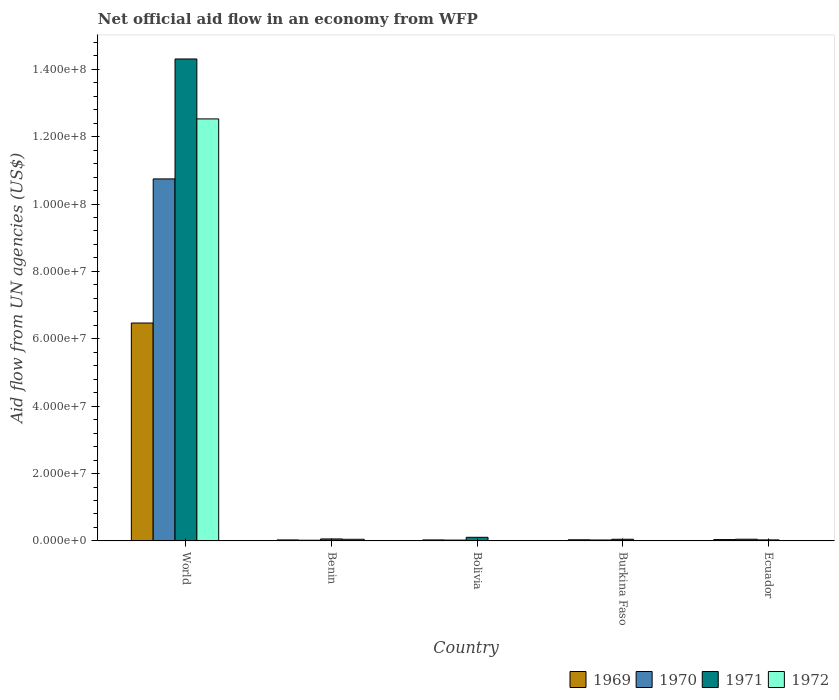How many groups of bars are there?
Ensure brevity in your answer.  5. How many bars are there on the 2nd tick from the left?
Provide a succinct answer. 4. How many bars are there on the 2nd tick from the right?
Ensure brevity in your answer.  4. What is the label of the 1st group of bars from the left?
Your response must be concise. World. In how many cases, is the number of bars for a given country not equal to the number of legend labels?
Provide a succinct answer. 1. What is the net official aid flow in 1972 in World?
Your response must be concise. 1.25e+08. Across all countries, what is the maximum net official aid flow in 1970?
Your answer should be very brief. 1.07e+08. Across all countries, what is the minimum net official aid flow in 1971?
Make the answer very short. 3.10e+05. In which country was the net official aid flow in 1969 maximum?
Provide a succinct answer. World. What is the total net official aid flow in 1972 in the graph?
Give a very brief answer. 1.26e+08. What is the difference between the net official aid flow in 1970 in Benin and that in Ecuador?
Offer a very short reply. -3.00e+05. What is the difference between the net official aid flow in 1971 in Burkina Faso and the net official aid flow in 1970 in Ecuador?
Keep it short and to the point. -10000. What is the average net official aid flow in 1970 per country?
Your answer should be very brief. 2.17e+07. What is the difference between the net official aid flow of/in 1970 and net official aid flow of/in 1971 in Bolivia?
Keep it short and to the point. -8.30e+05. In how many countries, is the net official aid flow in 1970 greater than 64000000 US$?
Keep it short and to the point. 1. What is the ratio of the net official aid flow in 1971 in Ecuador to that in World?
Your answer should be very brief. 0. Is the net official aid flow in 1969 in Benin less than that in Bolivia?
Give a very brief answer. No. What is the difference between the highest and the second highest net official aid flow in 1970?
Give a very brief answer. 1.07e+08. What is the difference between the highest and the lowest net official aid flow in 1970?
Ensure brevity in your answer.  1.07e+08. Is the sum of the net official aid flow in 1972 in Ecuador and World greater than the maximum net official aid flow in 1970 across all countries?
Your response must be concise. Yes. Is it the case that in every country, the sum of the net official aid flow in 1972 and net official aid flow in 1971 is greater than the net official aid flow in 1970?
Your answer should be very brief. No. How many bars are there?
Provide a short and direct response. 19. Are all the bars in the graph horizontal?
Your response must be concise. No. What is the difference between two consecutive major ticks on the Y-axis?
Ensure brevity in your answer.  2.00e+07. Are the values on the major ticks of Y-axis written in scientific E-notation?
Ensure brevity in your answer.  Yes. How many legend labels are there?
Offer a terse response. 4. What is the title of the graph?
Keep it short and to the point. Net official aid flow in an economy from WFP. What is the label or title of the X-axis?
Your response must be concise. Country. What is the label or title of the Y-axis?
Your response must be concise. Aid flow from UN agencies (US$). What is the Aid flow from UN agencies (US$) in 1969 in World?
Give a very brief answer. 6.47e+07. What is the Aid flow from UN agencies (US$) of 1970 in World?
Offer a very short reply. 1.07e+08. What is the Aid flow from UN agencies (US$) in 1971 in World?
Give a very brief answer. 1.43e+08. What is the Aid flow from UN agencies (US$) in 1972 in World?
Offer a very short reply. 1.25e+08. What is the Aid flow from UN agencies (US$) in 1969 in Benin?
Your answer should be very brief. 3.00e+05. What is the Aid flow from UN agencies (US$) of 1971 in Benin?
Provide a succinct answer. 5.90e+05. What is the Aid flow from UN agencies (US$) of 1971 in Bolivia?
Ensure brevity in your answer.  1.08e+06. What is the Aid flow from UN agencies (US$) in 1969 in Burkina Faso?
Make the answer very short. 3.40e+05. What is the Aid flow from UN agencies (US$) in 1972 in Burkina Faso?
Give a very brief answer. 9.00e+04. What is the Aid flow from UN agencies (US$) of 1969 in Ecuador?
Provide a short and direct response. 4.00e+05. What is the Aid flow from UN agencies (US$) in 1970 in Ecuador?
Offer a very short reply. 5.10e+05. What is the Aid flow from UN agencies (US$) of 1972 in Ecuador?
Give a very brief answer. 7.00e+04. Across all countries, what is the maximum Aid flow from UN agencies (US$) in 1969?
Your answer should be very brief. 6.47e+07. Across all countries, what is the maximum Aid flow from UN agencies (US$) in 1970?
Provide a succinct answer. 1.07e+08. Across all countries, what is the maximum Aid flow from UN agencies (US$) of 1971?
Provide a short and direct response. 1.43e+08. Across all countries, what is the maximum Aid flow from UN agencies (US$) in 1972?
Your response must be concise. 1.25e+08. Across all countries, what is the minimum Aid flow from UN agencies (US$) of 1969?
Offer a very short reply. 3.00e+05. Across all countries, what is the minimum Aid flow from UN agencies (US$) of 1970?
Ensure brevity in your answer.  2.10e+05. Across all countries, what is the minimum Aid flow from UN agencies (US$) of 1972?
Ensure brevity in your answer.  0. What is the total Aid flow from UN agencies (US$) in 1969 in the graph?
Keep it short and to the point. 6.60e+07. What is the total Aid flow from UN agencies (US$) of 1970 in the graph?
Offer a very short reply. 1.09e+08. What is the total Aid flow from UN agencies (US$) of 1971 in the graph?
Your response must be concise. 1.46e+08. What is the total Aid flow from UN agencies (US$) in 1972 in the graph?
Keep it short and to the point. 1.26e+08. What is the difference between the Aid flow from UN agencies (US$) of 1969 in World and that in Benin?
Offer a very short reply. 6.44e+07. What is the difference between the Aid flow from UN agencies (US$) of 1970 in World and that in Benin?
Keep it short and to the point. 1.07e+08. What is the difference between the Aid flow from UN agencies (US$) in 1971 in World and that in Benin?
Make the answer very short. 1.42e+08. What is the difference between the Aid flow from UN agencies (US$) in 1972 in World and that in Benin?
Make the answer very short. 1.25e+08. What is the difference between the Aid flow from UN agencies (US$) in 1969 in World and that in Bolivia?
Offer a terse response. 6.44e+07. What is the difference between the Aid flow from UN agencies (US$) of 1970 in World and that in Bolivia?
Offer a very short reply. 1.07e+08. What is the difference between the Aid flow from UN agencies (US$) of 1971 in World and that in Bolivia?
Offer a terse response. 1.42e+08. What is the difference between the Aid flow from UN agencies (US$) of 1969 in World and that in Burkina Faso?
Your answer should be compact. 6.44e+07. What is the difference between the Aid flow from UN agencies (US$) in 1970 in World and that in Burkina Faso?
Make the answer very short. 1.07e+08. What is the difference between the Aid flow from UN agencies (US$) of 1971 in World and that in Burkina Faso?
Provide a succinct answer. 1.43e+08. What is the difference between the Aid flow from UN agencies (US$) in 1972 in World and that in Burkina Faso?
Give a very brief answer. 1.25e+08. What is the difference between the Aid flow from UN agencies (US$) in 1969 in World and that in Ecuador?
Provide a succinct answer. 6.43e+07. What is the difference between the Aid flow from UN agencies (US$) of 1970 in World and that in Ecuador?
Your response must be concise. 1.07e+08. What is the difference between the Aid flow from UN agencies (US$) of 1971 in World and that in Ecuador?
Offer a very short reply. 1.43e+08. What is the difference between the Aid flow from UN agencies (US$) of 1972 in World and that in Ecuador?
Offer a terse response. 1.25e+08. What is the difference between the Aid flow from UN agencies (US$) in 1971 in Benin and that in Bolivia?
Keep it short and to the point. -4.90e+05. What is the difference between the Aid flow from UN agencies (US$) in 1971 in Benin and that in Burkina Faso?
Your answer should be very brief. 9.00e+04. What is the difference between the Aid flow from UN agencies (US$) in 1971 in Benin and that in Ecuador?
Your answer should be very brief. 2.80e+05. What is the difference between the Aid flow from UN agencies (US$) of 1972 in Benin and that in Ecuador?
Keep it short and to the point. 4.20e+05. What is the difference between the Aid flow from UN agencies (US$) in 1970 in Bolivia and that in Burkina Faso?
Provide a short and direct response. -3.00e+04. What is the difference between the Aid flow from UN agencies (US$) in 1971 in Bolivia and that in Burkina Faso?
Keep it short and to the point. 5.80e+05. What is the difference between the Aid flow from UN agencies (US$) of 1969 in Bolivia and that in Ecuador?
Make the answer very short. -1.00e+05. What is the difference between the Aid flow from UN agencies (US$) in 1971 in Bolivia and that in Ecuador?
Your response must be concise. 7.70e+05. What is the difference between the Aid flow from UN agencies (US$) in 1969 in Burkina Faso and that in Ecuador?
Your answer should be very brief. -6.00e+04. What is the difference between the Aid flow from UN agencies (US$) in 1970 in Burkina Faso and that in Ecuador?
Make the answer very short. -2.30e+05. What is the difference between the Aid flow from UN agencies (US$) of 1971 in Burkina Faso and that in Ecuador?
Your answer should be compact. 1.90e+05. What is the difference between the Aid flow from UN agencies (US$) of 1972 in Burkina Faso and that in Ecuador?
Your answer should be very brief. 2.00e+04. What is the difference between the Aid flow from UN agencies (US$) in 1969 in World and the Aid flow from UN agencies (US$) in 1970 in Benin?
Your answer should be very brief. 6.45e+07. What is the difference between the Aid flow from UN agencies (US$) of 1969 in World and the Aid flow from UN agencies (US$) of 1971 in Benin?
Offer a very short reply. 6.41e+07. What is the difference between the Aid flow from UN agencies (US$) in 1969 in World and the Aid flow from UN agencies (US$) in 1972 in Benin?
Offer a terse response. 6.42e+07. What is the difference between the Aid flow from UN agencies (US$) of 1970 in World and the Aid flow from UN agencies (US$) of 1971 in Benin?
Make the answer very short. 1.07e+08. What is the difference between the Aid flow from UN agencies (US$) of 1970 in World and the Aid flow from UN agencies (US$) of 1972 in Benin?
Keep it short and to the point. 1.07e+08. What is the difference between the Aid flow from UN agencies (US$) of 1971 in World and the Aid flow from UN agencies (US$) of 1972 in Benin?
Your answer should be very brief. 1.43e+08. What is the difference between the Aid flow from UN agencies (US$) of 1969 in World and the Aid flow from UN agencies (US$) of 1970 in Bolivia?
Ensure brevity in your answer.  6.44e+07. What is the difference between the Aid flow from UN agencies (US$) of 1969 in World and the Aid flow from UN agencies (US$) of 1971 in Bolivia?
Make the answer very short. 6.36e+07. What is the difference between the Aid flow from UN agencies (US$) in 1970 in World and the Aid flow from UN agencies (US$) in 1971 in Bolivia?
Provide a short and direct response. 1.06e+08. What is the difference between the Aid flow from UN agencies (US$) of 1969 in World and the Aid flow from UN agencies (US$) of 1970 in Burkina Faso?
Provide a short and direct response. 6.44e+07. What is the difference between the Aid flow from UN agencies (US$) in 1969 in World and the Aid flow from UN agencies (US$) in 1971 in Burkina Faso?
Your answer should be compact. 6.42e+07. What is the difference between the Aid flow from UN agencies (US$) of 1969 in World and the Aid flow from UN agencies (US$) of 1972 in Burkina Faso?
Offer a terse response. 6.46e+07. What is the difference between the Aid flow from UN agencies (US$) in 1970 in World and the Aid flow from UN agencies (US$) in 1971 in Burkina Faso?
Provide a short and direct response. 1.07e+08. What is the difference between the Aid flow from UN agencies (US$) of 1970 in World and the Aid flow from UN agencies (US$) of 1972 in Burkina Faso?
Your answer should be very brief. 1.07e+08. What is the difference between the Aid flow from UN agencies (US$) of 1971 in World and the Aid flow from UN agencies (US$) of 1972 in Burkina Faso?
Give a very brief answer. 1.43e+08. What is the difference between the Aid flow from UN agencies (US$) of 1969 in World and the Aid flow from UN agencies (US$) of 1970 in Ecuador?
Make the answer very short. 6.42e+07. What is the difference between the Aid flow from UN agencies (US$) in 1969 in World and the Aid flow from UN agencies (US$) in 1971 in Ecuador?
Your answer should be compact. 6.44e+07. What is the difference between the Aid flow from UN agencies (US$) of 1969 in World and the Aid flow from UN agencies (US$) of 1972 in Ecuador?
Your answer should be very brief. 6.46e+07. What is the difference between the Aid flow from UN agencies (US$) in 1970 in World and the Aid flow from UN agencies (US$) in 1971 in Ecuador?
Provide a succinct answer. 1.07e+08. What is the difference between the Aid flow from UN agencies (US$) of 1970 in World and the Aid flow from UN agencies (US$) of 1972 in Ecuador?
Provide a short and direct response. 1.07e+08. What is the difference between the Aid flow from UN agencies (US$) of 1971 in World and the Aid flow from UN agencies (US$) of 1972 in Ecuador?
Offer a very short reply. 1.43e+08. What is the difference between the Aid flow from UN agencies (US$) in 1969 in Benin and the Aid flow from UN agencies (US$) in 1970 in Bolivia?
Make the answer very short. 5.00e+04. What is the difference between the Aid flow from UN agencies (US$) of 1969 in Benin and the Aid flow from UN agencies (US$) of 1971 in Bolivia?
Offer a very short reply. -7.80e+05. What is the difference between the Aid flow from UN agencies (US$) of 1970 in Benin and the Aid flow from UN agencies (US$) of 1971 in Bolivia?
Give a very brief answer. -8.70e+05. What is the difference between the Aid flow from UN agencies (US$) of 1969 in Benin and the Aid flow from UN agencies (US$) of 1970 in Burkina Faso?
Provide a succinct answer. 2.00e+04. What is the difference between the Aid flow from UN agencies (US$) of 1969 in Benin and the Aid flow from UN agencies (US$) of 1971 in Burkina Faso?
Offer a terse response. -2.00e+05. What is the difference between the Aid flow from UN agencies (US$) of 1969 in Benin and the Aid flow from UN agencies (US$) of 1972 in Burkina Faso?
Make the answer very short. 2.10e+05. What is the difference between the Aid flow from UN agencies (US$) of 1970 in Benin and the Aid flow from UN agencies (US$) of 1972 in Burkina Faso?
Provide a succinct answer. 1.20e+05. What is the difference between the Aid flow from UN agencies (US$) in 1969 in Benin and the Aid flow from UN agencies (US$) in 1971 in Ecuador?
Ensure brevity in your answer.  -10000. What is the difference between the Aid flow from UN agencies (US$) in 1969 in Benin and the Aid flow from UN agencies (US$) in 1972 in Ecuador?
Provide a short and direct response. 2.30e+05. What is the difference between the Aid flow from UN agencies (US$) in 1970 in Benin and the Aid flow from UN agencies (US$) in 1971 in Ecuador?
Offer a very short reply. -1.00e+05. What is the difference between the Aid flow from UN agencies (US$) in 1970 in Benin and the Aid flow from UN agencies (US$) in 1972 in Ecuador?
Your answer should be compact. 1.40e+05. What is the difference between the Aid flow from UN agencies (US$) of 1971 in Benin and the Aid flow from UN agencies (US$) of 1972 in Ecuador?
Your response must be concise. 5.20e+05. What is the difference between the Aid flow from UN agencies (US$) of 1969 in Bolivia and the Aid flow from UN agencies (US$) of 1970 in Burkina Faso?
Offer a terse response. 2.00e+04. What is the difference between the Aid flow from UN agencies (US$) of 1969 in Bolivia and the Aid flow from UN agencies (US$) of 1971 in Burkina Faso?
Provide a succinct answer. -2.00e+05. What is the difference between the Aid flow from UN agencies (US$) in 1969 in Bolivia and the Aid flow from UN agencies (US$) in 1972 in Burkina Faso?
Provide a short and direct response. 2.10e+05. What is the difference between the Aid flow from UN agencies (US$) of 1970 in Bolivia and the Aid flow from UN agencies (US$) of 1971 in Burkina Faso?
Provide a short and direct response. -2.50e+05. What is the difference between the Aid flow from UN agencies (US$) of 1970 in Bolivia and the Aid flow from UN agencies (US$) of 1972 in Burkina Faso?
Give a very brief answer. 1.60e+05. What is the difference between the Aid flow from UN agencies (US$) in 1971 in Bolivia and the Aid flow from UN agencies (US$) in 1972 in Burkina Faso?
Make the answer very short. 9.90e+05. What is the difference between the Aid flow from UN agencies (US$) in 1969 in Bolivia and the Aid flow from UN agencies (US$) in 1971 in Ecuador?
Your answer should be compact. -10000. What is the difference between the Aid flow from UN agencies (US$) in 1969 in Bolivia and the Aid flow from UN agencies (US$) in 1972 in Ecuador?
Offer a very short reply. 2.30e+05. What is the difference between the Aid flow from UN agencies (US$) in 1970 in Bolivia and the Aid flow from UN agencies (US$) in 1971 in Ecuador?
Keep it short and to the point. -6.00e+04. What is the difference between the Aid flow from UN agencies (US$) of 1971 in Bolivia and the Aid flow from UN agencies (US$) of 1972 in Ecuador?
Make the answer very short. 1.01e+06. What is the difference between the Aid flow from UN agencies (US$) of 1970 in Burkina Faso and the Aid flow from UN agencies (US$) of 1971 in Ecuador?
Ensure brevity in your answer.  -3.00e+04. What is the difference between the Aid flow from UN agencies (US$) in 1970 in Burkina Faso and the Aid flow from UN agencies (US$) in 1972 in Ecuador?
Offer a terse response. 2.10e+05. What is the average Aid flow from UN agencies (US$) of 1969 per country?
Offer a very short reply. 1.32e+07. What is the average Aid flow from UN agencies (US$) of 1970 per country?
Your answer should be compact. 2.17e+07. What is the average Aid flow from UN agencies (US$) in 1971 per country?
Give a very brief answer. 2.91e+07. What is the average Aid flow from UN agencies (US$) of 1972 per country?
Keep it short and to the point. 2.52e+07. What is the difference between the Aid flow from UN agencies (US$) of 1969 and Aid flow from UN agencies (US$) of 1970 in World?
Give a very brief answer. -4.28e+07. What is the difference between the Aid flow from UN agencies (US$) in 1969 and Aid flow from UN agencies (US$) in 1971 in World?
Offer a terse response. -7.84e+07. What is the difference between the Aid flow from UN agencies (US$) in 1969 and Aid flow from UN agencies (US$) in 1972 in World?
Ensure brevity in your answer.  -6.06e+07. What is the difference between the Aid flow from UN agencies (US$) of 1970 and Aid flow from UN agencies (US$) of 1971 in World?
Your answer should be compact. -3.56e+07. What is the difference between the Aid flow from UN agencies (US$) of 1970 and Aid flow from UN agencies (US$) of 1972 in World?
Your answer should be very brief. -1.78e+07. What is the difference between the Aid flow from UN agencies (US$) in 1971 and Aid flow from UN agencies (US$) in 1972 in World?
Provide a short and direct response. 1.78e+07. What is the difference between the Aid flow from UN agencies (US$) of 1969 and Aid flow from UN agencies (US$) of 1970 in Benin?
Your response must be concise. 9.00e+04. What is the difference between the Aid flow from UN agencies (US$) in 1969 and Aid flow from UN agencies (US$) in 1972 in Benin?
Your response must be concise. -1.90e+05. What is the difference between the Aid flow from UN agencies (US$) in 1970 and Aid flow from UN agencies (US$) in 1971 in Benin?
Your response must be concise. -3.80e+05. What is the difference between the Aid flow from UN agencies (US$) in 1970 and Aid flow from UN agencies (US$) in 1972 in Benin?
Offer a terse response. -2.80e+05. What is the difference between the Aid flow from UN agencies (US$) in 1969 and Aid flow from UN agencies (US$) in 1970 in Bolivia?
Provide a short and direct response. 5.00e+04. What is the difference between the Aid flow from UN agencies (US$) of 1969 and Aid flow from UN agencies (US$) of 1971 in Bolivia?
Provide a succinct answer. -7.80e+05. What is the difference between the Aid flow from UN agencies (US$) in 1970 and Aid flow from UN agencies (US$) in 1971 in Bolivia?
Give a very brief answer. -8.30e+05. What is the difference between the Aid flow from UN agencies (US$) of 1969 and Aid flow from UN agencies (US$) of 1971 in Burkina Faso?
Your answer should be very brief. -1.60e+05. What is the difference between the Aid flow from UN agencies (US$) in 1970 and Aid flow from UN agencies (US$) in 1972 in Burkina Faso?
Offer a very short reply. 1.90e+05. What is the difference between the Aid flow from UN agencies (US$) in 1971 and Aid flow from UN agencies (US$) in 1972 in Burkina Faso?
Offer a very short reply. 4.10e+05. What is the difference between the Aid flow from UN agencies (US$) of 1969 and Aid flow from UN agencies (US$) of 1970 in Ecuador?
Provide a succinct answer. -1.10e+05. What is the difference between the Aid flow from UN agencies (US$) of 1970 and Aid flow from UN agencies (US$) of 1972 in Ecuador?
Make the answer very short. 4.40e+05. What is the difference between the Aid flow from UN agencies (US$) of 1971 and Aid flow from UN agencies (US$) of 1972 in Ecuador?
Your response must be concise. 2.40e+05. What is the ratio of the Aid flow from UN agencies (US$) of 1969 in World to that in Benin?
Provide a short and direct response. 215.63. What is the ratio of the Aid flow from UN agencies (US$) of 1970 in World to that in Benin?
Ensure brevity in your answer.  511.71. What is the ratio of the Aid flow from UN agencies (US$) of 1971 in World to that in Benin?
Provide a succinct answer. 242.47. What is the ratio of the Aid flow from UN agencies (US$) in 1972 in World to that in Benin?
Give a very brief answer. 255.65. What is the ratio of the Aid flow from UN agencies (US$) in 1969 in World to that in Bolivia?
Your response must be concise. 215.63. What is the ratio of the Aid flow from UN agencies (US$) of 1970 in World to that in Bolivia?
Ensure brevity in your answer.  429.84. What is the ratio of the Aid flow from UN agencies (US$) in 1971 in World to that in Bolivia?
Give a very brief answer. 132.46. What is the ratio of the Aid flow from UN agencies (US$) of 1969 in World to that in Burkina Faso?
Offer a terse response. 190.26. What is the ratio of the Aid flow from UN agencies (US$) of 1970 in World to that in Burkina Faso?
Your answer should be very brief. 383.79. What is the ratio of the Aid flow from UN agencies (US$) in 1971 in World to that in Burkina Faso?
Your answer should be compact. 286.12. What is the ratio of the Aid flow from UN agencies (US$) in 1972 in World to that in Burkina Faso?
Ensure brevity in your answer.  1391.89. What is the ratio of the Aid flow from UN agencies (US$) in 1969 in World to that in Ecuador?
Your answer should be very brief. 161.72. What is the ratio of the Aid flow from UN agencies (US$) of 1970 in World to that in Ecuador?
Your answer should be compact. 210.71. What is the ratio of the Aid flow from UN agencies (US$) in 1971 in World to that in Ecuador?
Keep it short and to the point. 461.48. What is the ratio of the Aid flow from UN agencies (US$) of 1972 in World to that in Ecuador?
Ensure brevity in your answer.  1789.57. What is the ratio of the Aid flow from UN agencies (US$) of 1970 in Benin to that in Bolivia?
Give a very brief answer. 0.84. What is the ratio of the Aid flow from UN agencies (US$) in 1971 in Benin to that in Bolivia?
Offer a terse response. 0.55. What is the ratio of the Aid flow from UN agencies (US$) of 1969 in Benin to that in Burkina Faso?
Provide a succinct answer. 0.88. What is the ratio of the Aid flow from UN agencies (US$) of 1971 in Benin to that in Burkina Faso?
Give a very brief answer. 1.18. What is the ratio of the Aid flow from UN agencies (US$) in 1972 in Benin to that in Burkina Faso?
Ensure brevity in your answer.  5.44. What is the ratio of the Aid flow from UN agencies (US$) in 1969 in Benin to that in Ecuador?
Give a very brief answer. 0.75. What is the ratio of the Aid flow from UN agencies (US$) in 1970 in Benin to that in Ecuador?
Offer a very short reply. 0.41. What is the ratio of the Aid flow from UN agencies (US$) of 1971 in Benin to that in Ecuador?
Provide a succinct answer. 1.9. What is the ratio of the Aid flow from UN agencies (US$) of 1969 in Bolivia to that in Burkina Faso?
Your answer should be compact. 0.88. What is the ratio of the Aid flow from UN agencies (US$) in 1970 in Bolivia to that in Burkina Faso?
Provide a succinct answer. 0.89. What is the ratio of the Aid flow from UN agencies (US$) in 1971 in Bolivia to that in Burkina Faso?
Offer a very short reply. 2.16. What is the ratio of the Aid flow from UN agencies (US$) in 1970 in Bolivia to that in Ecuador?
Your answer should be very brief. 0.49. What is the ratio of the Aid flow from UN agencies (US$) in 1971 in Bolivia to that in Ecuador?
Offer a terse response. 3.48. What is the ratio of the Aid flow from UN agencies (US$) in 1969 in Burkina Faso to that in Ecuador?
Provide a succinct answer. 0.85. What is the ratio of the Aid flow from UN agencies (US$) of 1970 in Burkina Faso to that in Ecuador?
Provide a short and direct response. 0.55. What is the ratio of the Aid flow from UN agencies (US$) in 1971 in Burkina Faso to that in Ecuador?
Your answer should be very brief. 1.61. What is the difference between the highest and the second highest Aid flow from UN agencies (US$) in 1969?
Make the answer very short. 6.43e+07. What is the difference between the highest and the second highest Aid flow from UN agencies (US$) in 1970?
Your answer should be compact. 1.07e+08. What is the difference between the highest and the second highest Aid flow from UN agencies (US$) of 1971?
Make the answer very short. 1.42e+08. What is the difference between the highest and the second highest Aid flow from UN agencies (US$) of 1972?
Ensure brevity in your answer.  1.25e+08. What is the difference between the highest and the lowest Aid flow from UN agencies (US$) of 1969?
Ensure brevity in your answer.  6.44e+07. What is the difference between the highest and the lowest Aid flow from UN agencies (US$) in 1970?
Give a very brief answer. 1.07e+08. What is the difference between the highest and the lowest Aid flow from UN agencies (US$) in 1971?
Provide a short and direct response. 1.43e+08. What is the difference between the highest and the lowest Aid flow from UN agencies (US$) in 1972?
Offer a terse response. 1.25e+08. 